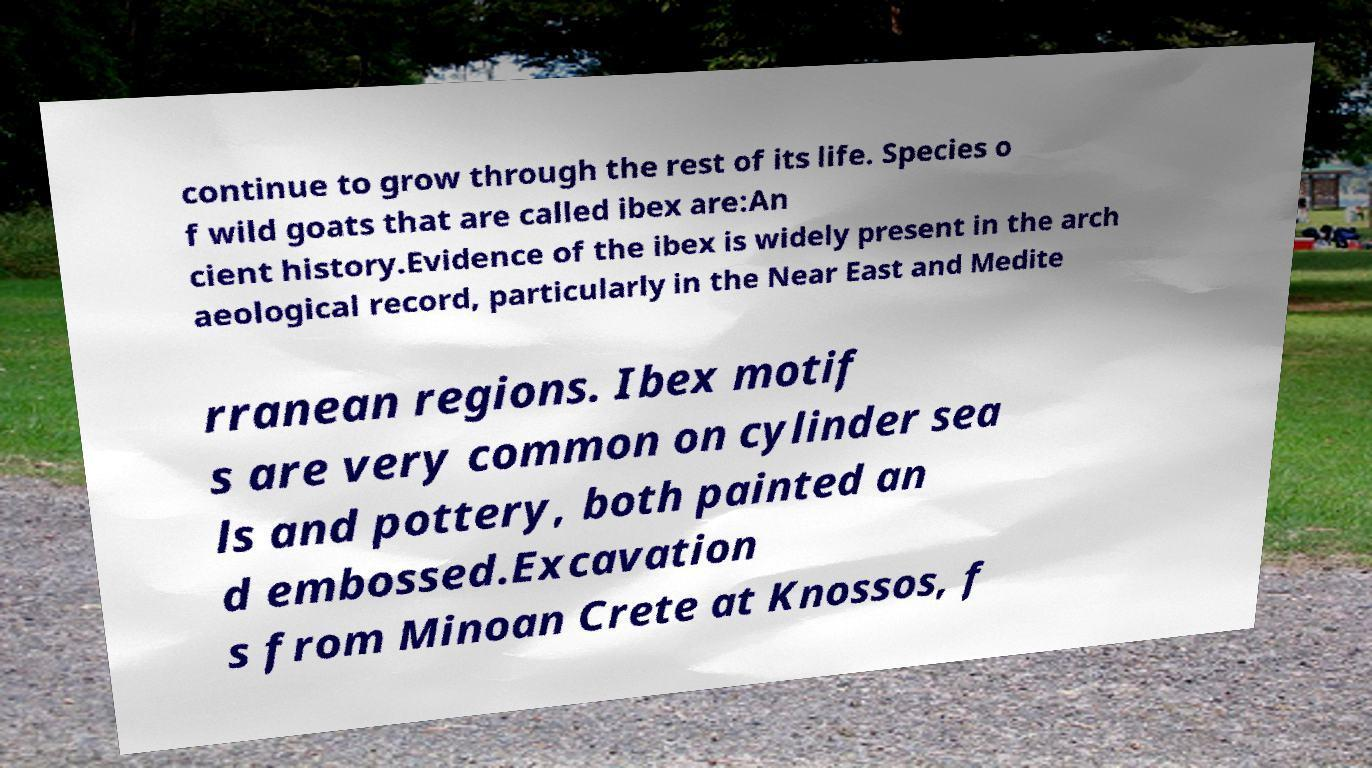Can you read and provide the text displayed in the image?This photo seems to have some interesting text. Can you extract and type it out for me? continue to grow through the rest of its life. Species o f wild goats that are called ibex are:An cient history.Evidence of the ibex is widely present in the arch aeological record, particularly in the Near East and Medite rranean regions. Ibex motif s are very common on cylinder sea ls and pottery, both painted an d embossed.Excavation s from Minoan Crete at Knossos, f 